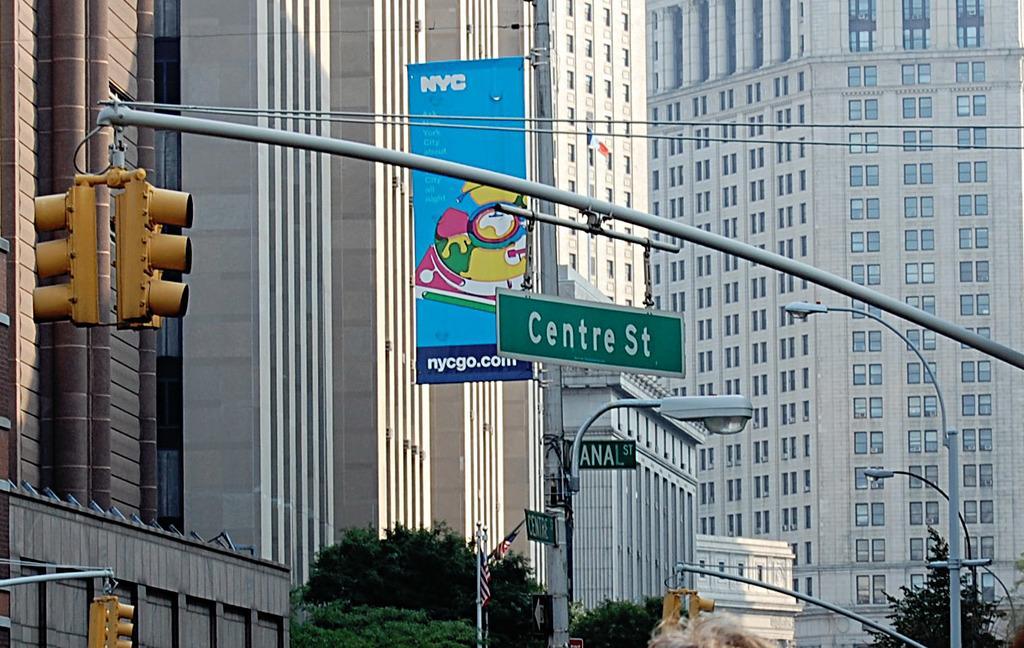Can you describe this image briefly? In this image in the center there are some buildings, and in the foreground there are some boards, traffic signals, poles and trees. 